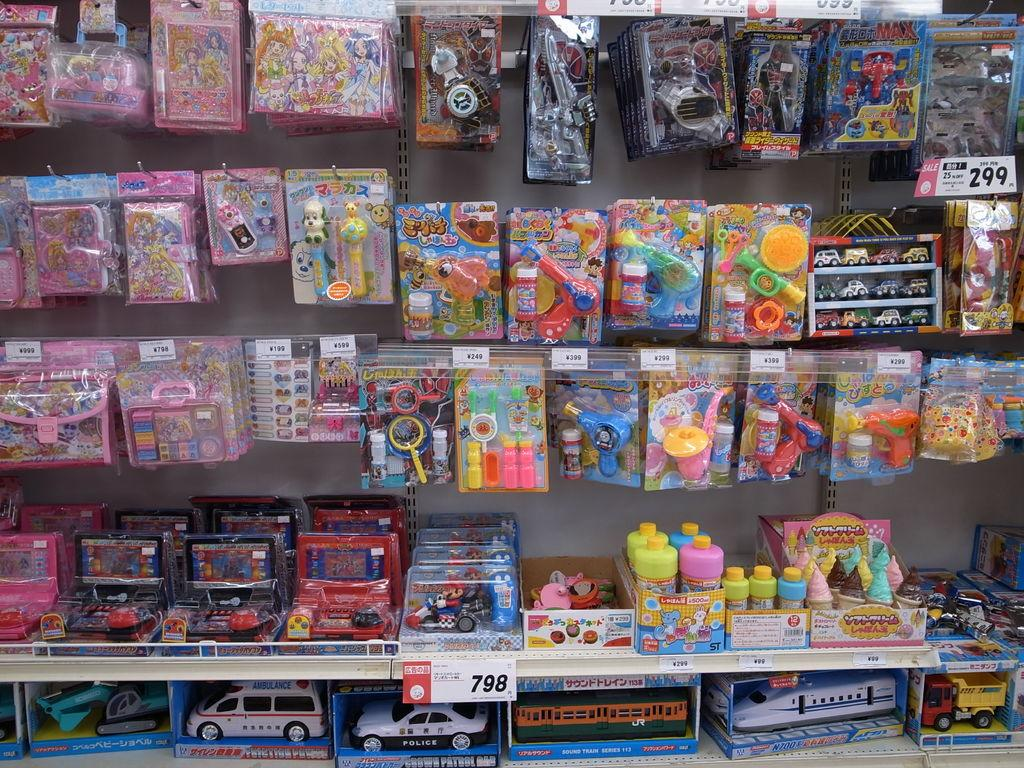<image>
Give a short and clear explanation of the subsequent image. a shelf of toys with a tag that says 798 underneath 